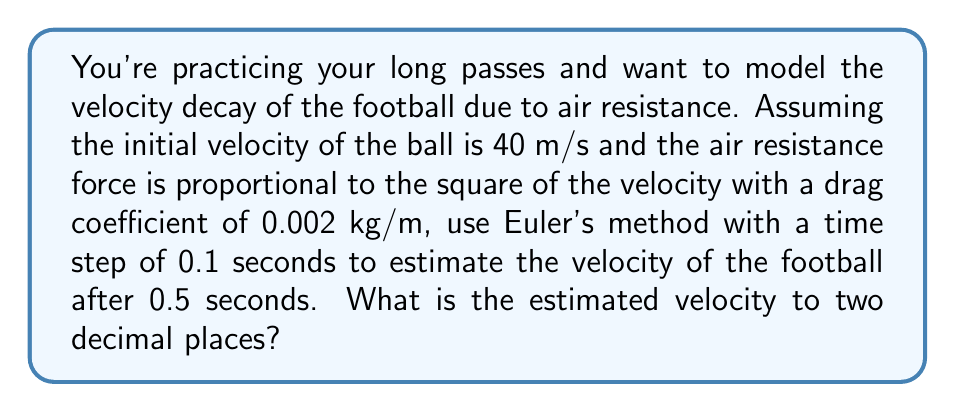Solve this math problem. Let's approach this step-by-step using Euler's method:

1) The differential equation for velocity decay due to air resistance is:

   $$\frac{dv}{dt} = -kv^2$$

   where $k$ is the drag coefficient divided by the mass of the football.

2) We're given:
   - Initial velocity $v_0 = 40$ m/s
   - Drag coefficient $k = 0.002$ kg/m
   - Time step $\Delta t = 0.1$ s
   - Total time $t = 0.5$ s

3) Euler's method states:

   $$v_{n+1} = v_n + \frac{dv}{dt}\Delta t = v_n - kv_n^2\Delta t$$

4) We need to apply this formula 5 times (0.5 s / 0.1 s = 5 steps):

   Step 1: $v_1 = 40 - 0.002(40^2)(0.1) = 40 - 3.2 = 36.8$ m/s
   
   Step 2: $v_2 = 36.8 - 0.002(36.8^2)(0.1) = 36.8 - 2.71 = 34.09$ m/s
   
   Step 3: $v_3 = 34.09 - 0.002(34.09^2)(0.1) = 34.09 - 2.32 = 31.77$ m/s
   
   Step 4: $v_4 = 31.77 - 0.002(31.77^2)(0.1) = 31.77 - 2.02 = 29.75$ m/s
   
   Step 5: $v_5 = 29.75 - 0.002(29.75^2)(0.1) = 29.75 - 1.77 = 27.98$ m/s

5) Therefore, the estimated velocity after 0.5 seconds is 27.98 m/s.

6) Rounding to two decimal places, we get 27.98 m/s.
Answer: 27.98 m/s 